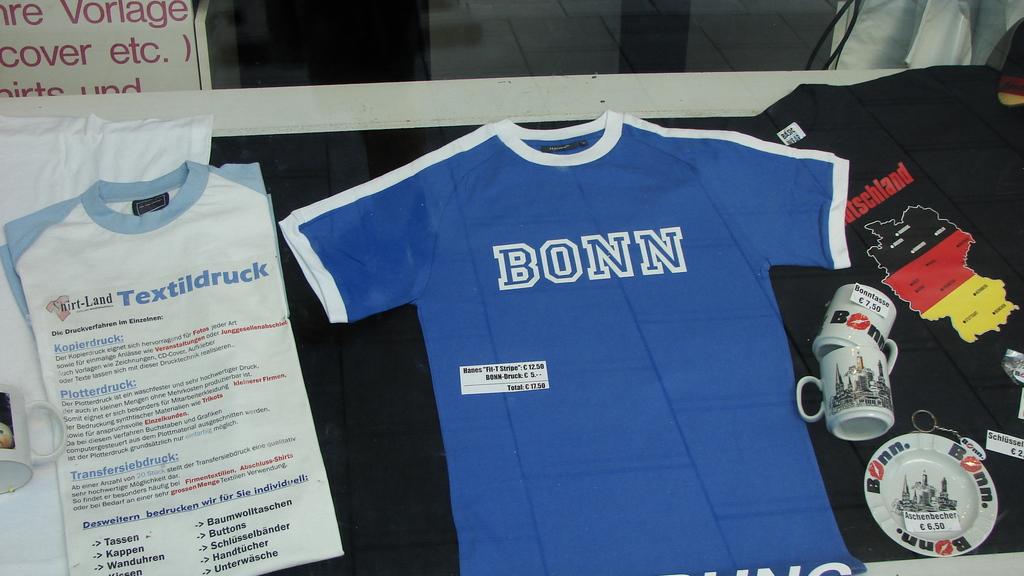What is written in blue on the white shirt?
Ensure brevity in your answer.  Bonn. 